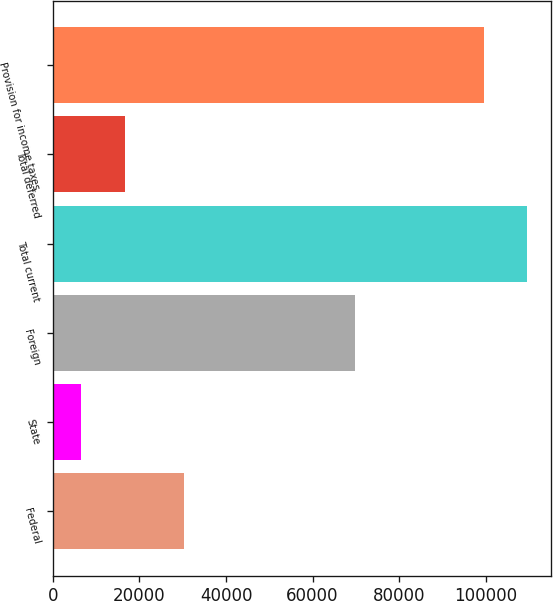Convert chart. <chart><loc_0><loc_0><loc_500><loc_500><bar_chart><fcel>Federal<fcel>State<fcel>Foreign<fcel>Total current<fcel>Total deferred<fcel>Provision for income taxes<nl><fcel>30334<fcel>6616<fcel>69793<fcel>109603<fcel>16628.7<fcel>99590<nl></chart> 